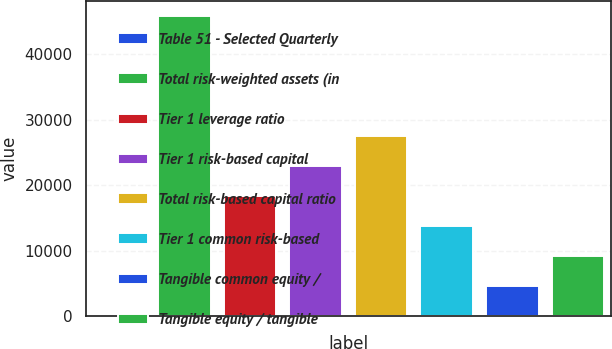<chart> <loc_0><loc_0><loc_500><loc_500><bar_chart><fcel>Table 51 - Selected Quarterly<fcel>Total risk-weighted assets (in<fcel>Tier 1 leverage ratio<fcel>Tier 1 risk-based capital<fcel>Total risk-based capital ratio<fcel>Tier 1 common risk-based<fcel>Tangible common equity /<fcel>Tangible equity / tangible<nl><fcel>1<fcel>45891<fcel>18357<fcel>22946<fcel>27535<fcel>13768<fcel>4590<fcel>9179<nl></chart> 